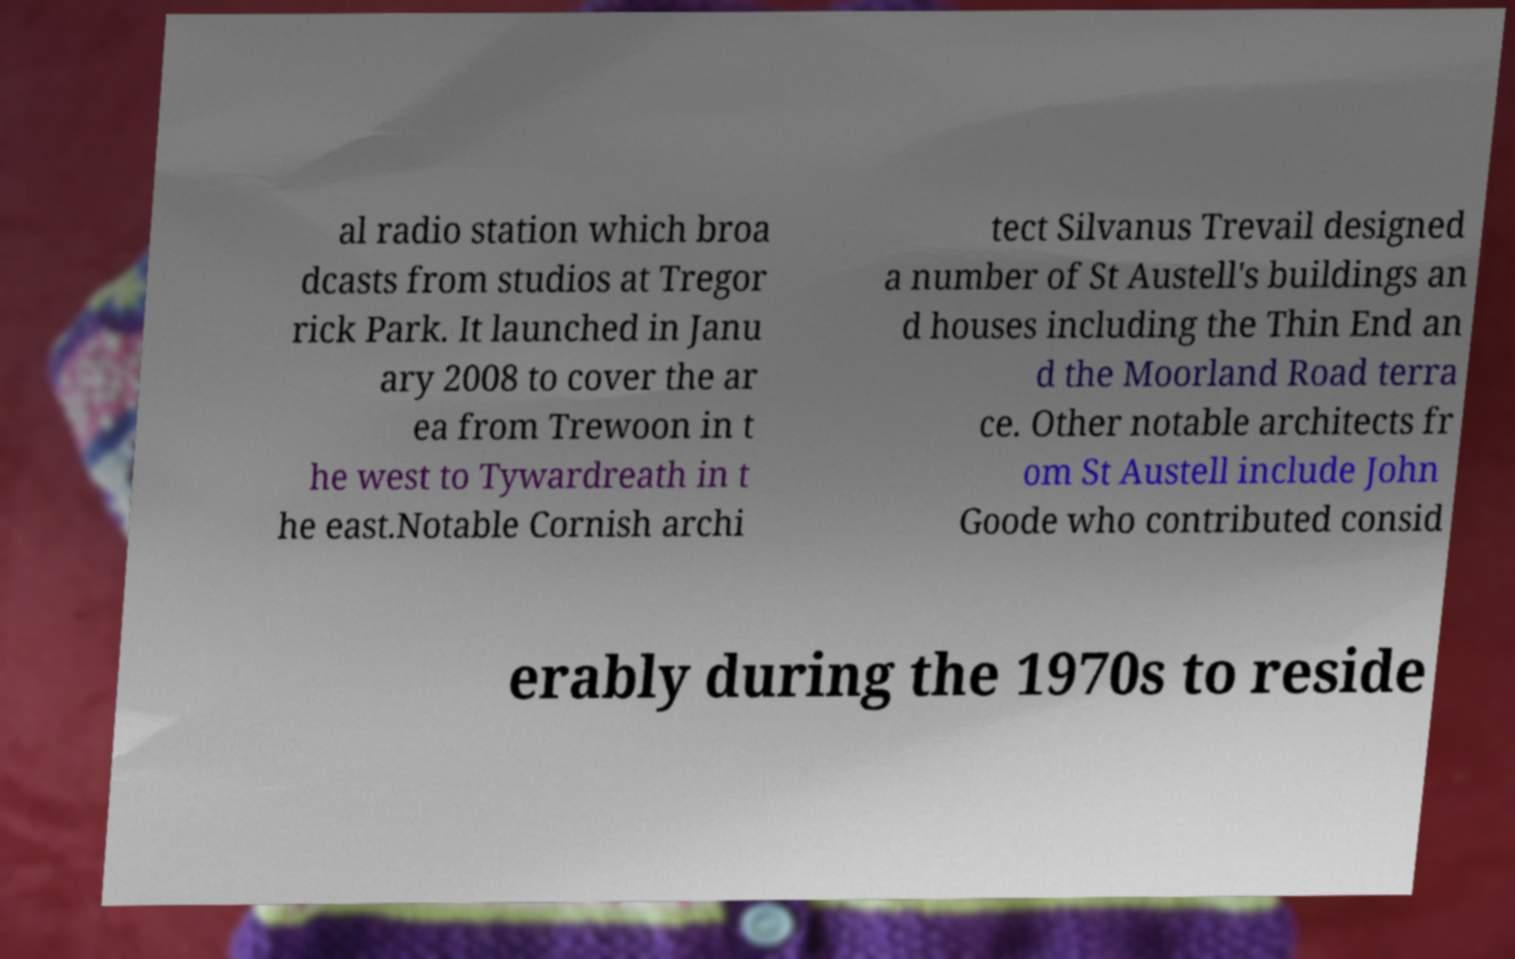Can you accurately transcribe the text from the provided image for me? al radio station which broa dcasts from studios at Tregor rick Park. It launched in Janu ary 2008 to cover the ar ea from Trewoon in t he west to Tywardreath in t he east.Notable Cornish archi tect Silvanus Trevail designed a number of St Austell's buildings an d houses including the Thin End an d the Moorland Road terra ce. Other notable architects fr om St Austell include John Goode who contributed consid erably during the 1970s to reside 